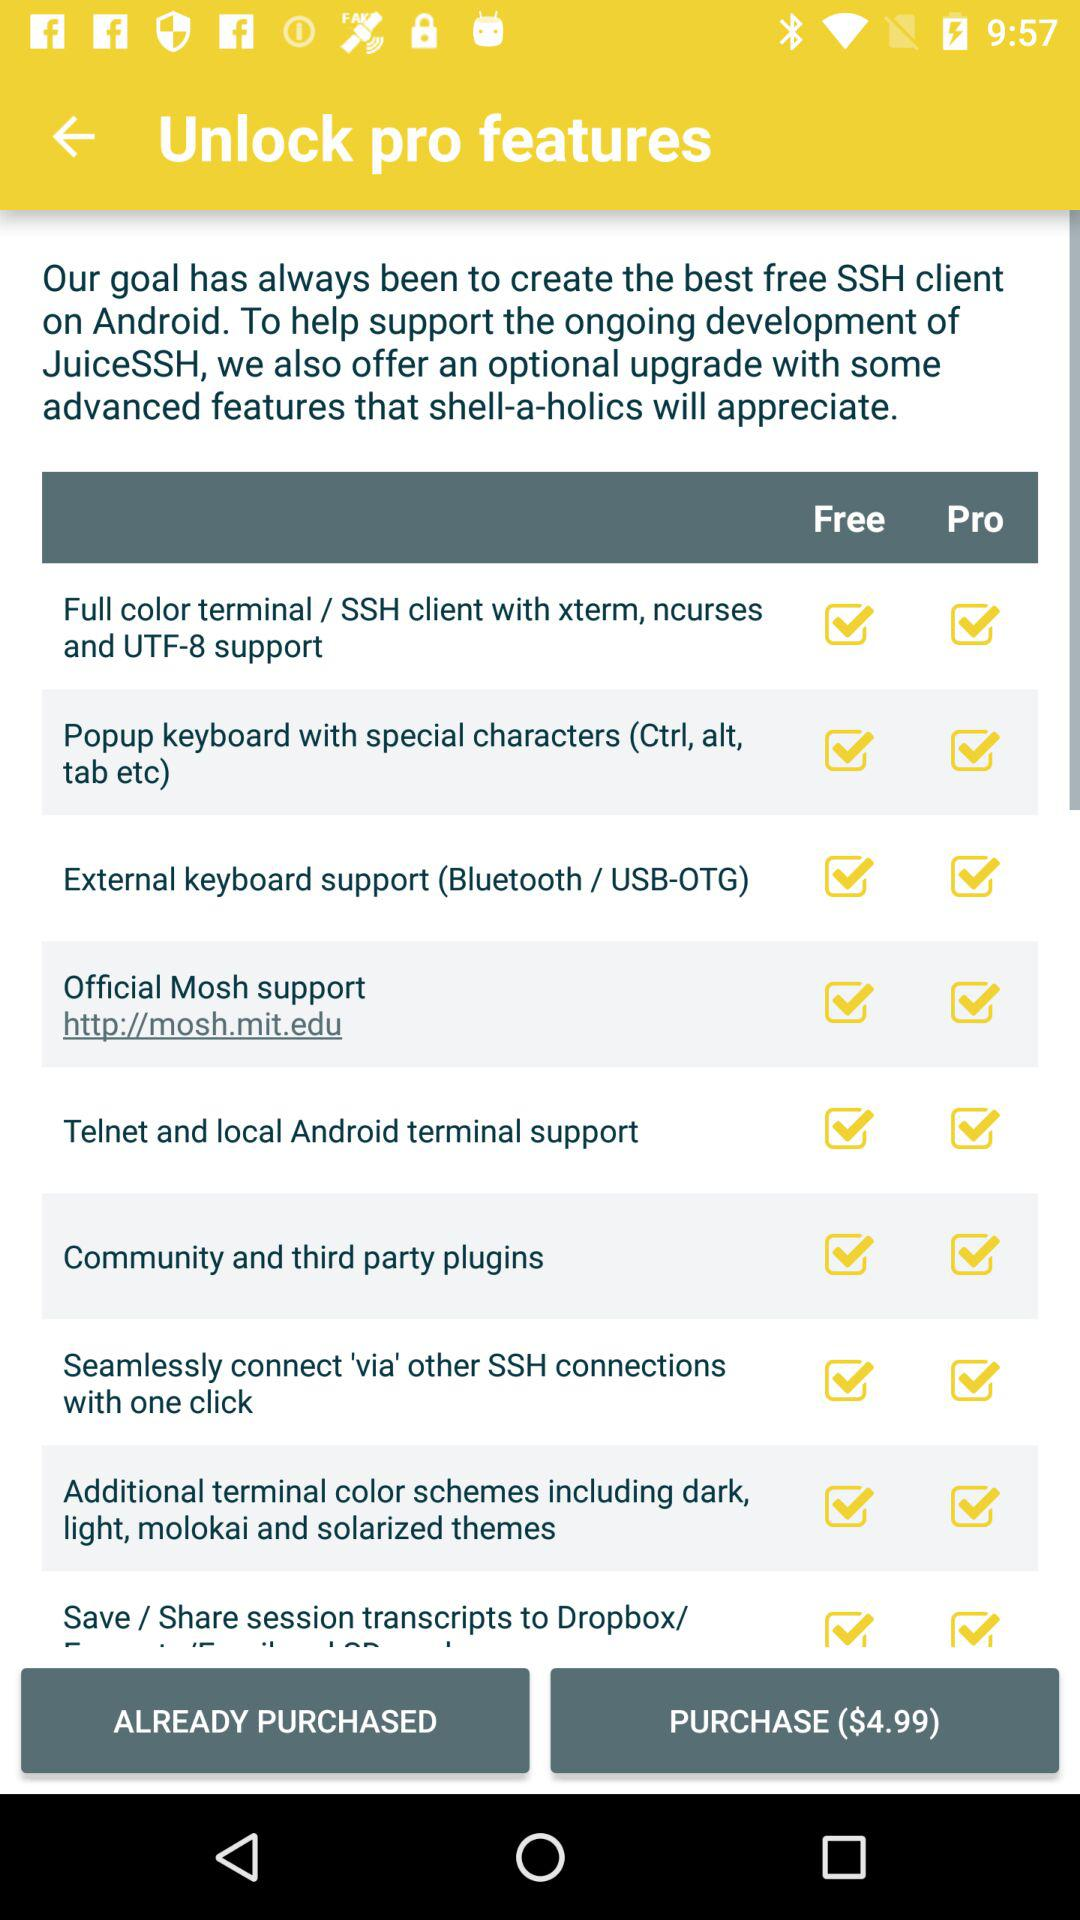Is Official Mosh support free or paid?
When the provided information is insufficient, respond with <no answer>. <no answer> 